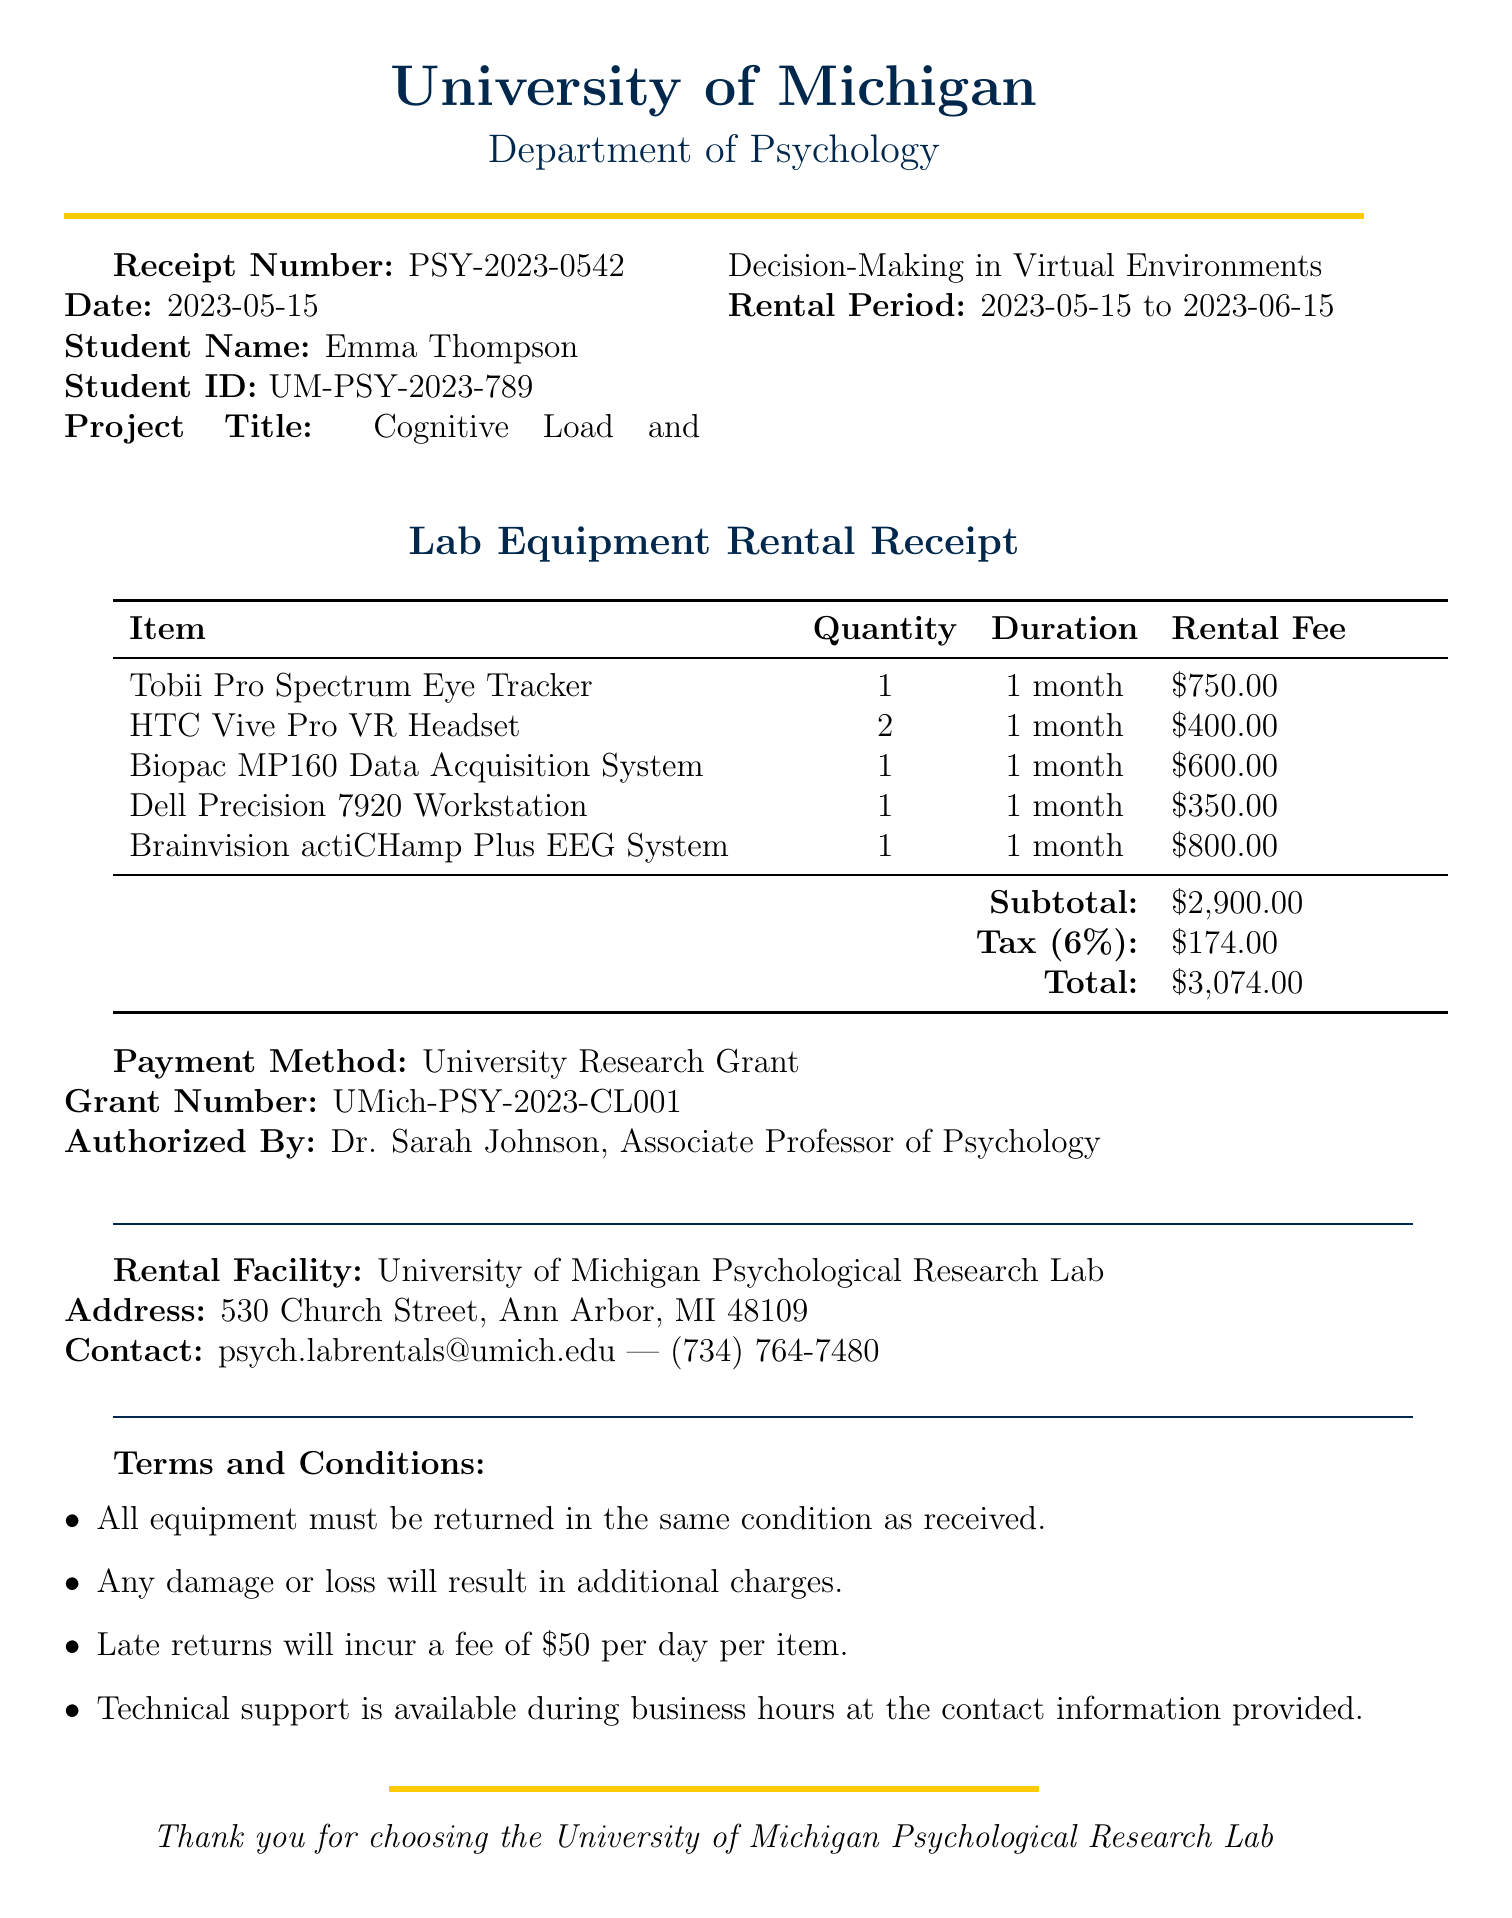What is the receipt number? The receipt number uniquely identifies this rental document as PSY-2023-0542.
Answer: PSY-2023-0542 What is the rental fee for the Tobii Pro Spectrum Eye Tracker? The rental fee for the Tobii Pro Spectrum Eye Tracker is listed as $750.00.
Answer: $750.00 Who is the authorized person for this transaction? The document states that Dr. Sarah Johnson authorized the rental.
Answer: Dr. Sarah Johnson What is the total amount due for the rental? The total amount is calculated as $2,900.00 plus tax amounting to $174.00, which equals $3,074.00.
Answer: $3,074.00 What is the rental period for the equipment? The rental period is defined as the duration from May 15, 2023, to June 15, 2023.
Answer: 2023-05-15 to 2023-06-15 How many HTC Vive Pro VR Headsets were rented? The quantity of HTC Vive Pro VR Headsets rented is stated as two in the document.
Answer: 2 What will happen if the equipment is returned late? The document specifies that late returns will incur a fee of $50 per day per item.
Answer: $50 per day per item Where is the rental facility located? The rental facility is located at 530 Church Street, Ann Arbor, MI 48109.
Answer: 530 Church Street, Ann Arbor, MI 48109 What is the contact email for lab rentals? The document provides the email address for lab rentals, which is psych.labrentals@umich.edu.
Answer: psych.labrentals@umich.edu 